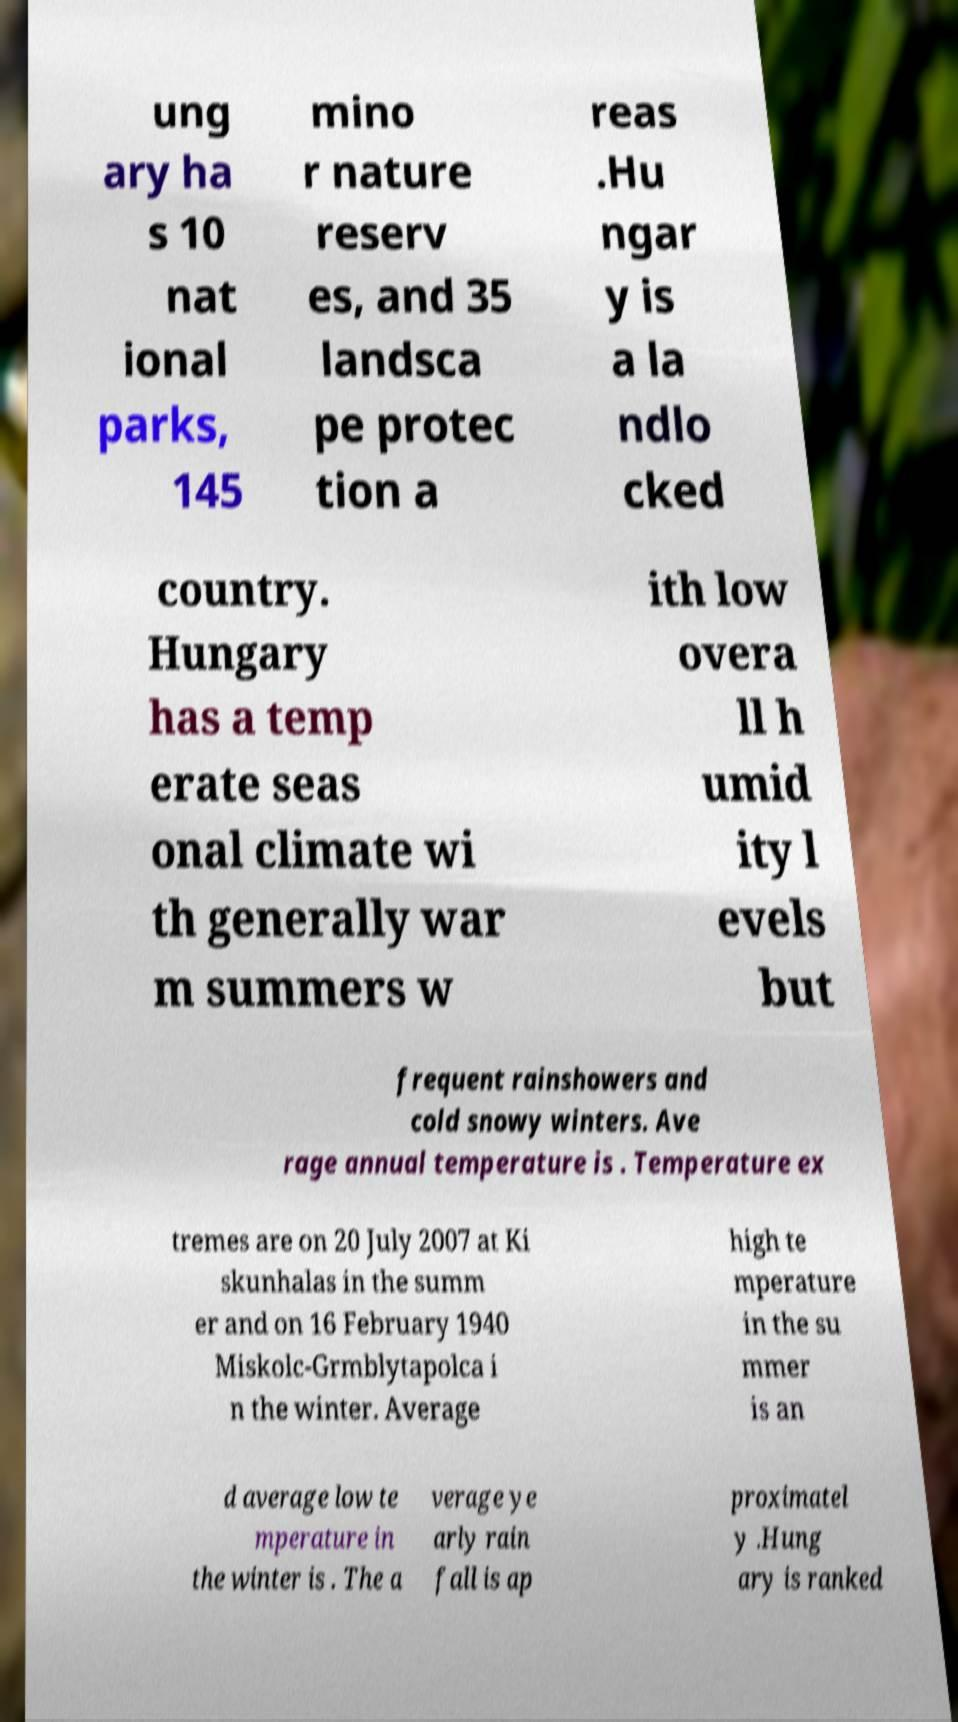Could you extract and type out the text from this image? ung ary ha s 10 nat ional parks, 145 mino r nature reserv es, and 35 landsca pe protec tion a reas .Hu ngar y is a la ndlo cked country. Hungary has a temp erate seas onal climate wi th generally war m summers w ith low overa ll h umid ity l evels but frequent rainshowers and cold snowy winters. Ave rage annual temperature is . Temperature ex tremes are on 20 July 2007 at Ki skunhalas in the summ er and on 16 February 1940 Miskolc-Grmblytapolca i n the winter. Average high te mperature in the su mmer is an d average low te mperature in the winter is . The a verage ye arly rain fall is ap proximatel y .Hung ary is ranked 